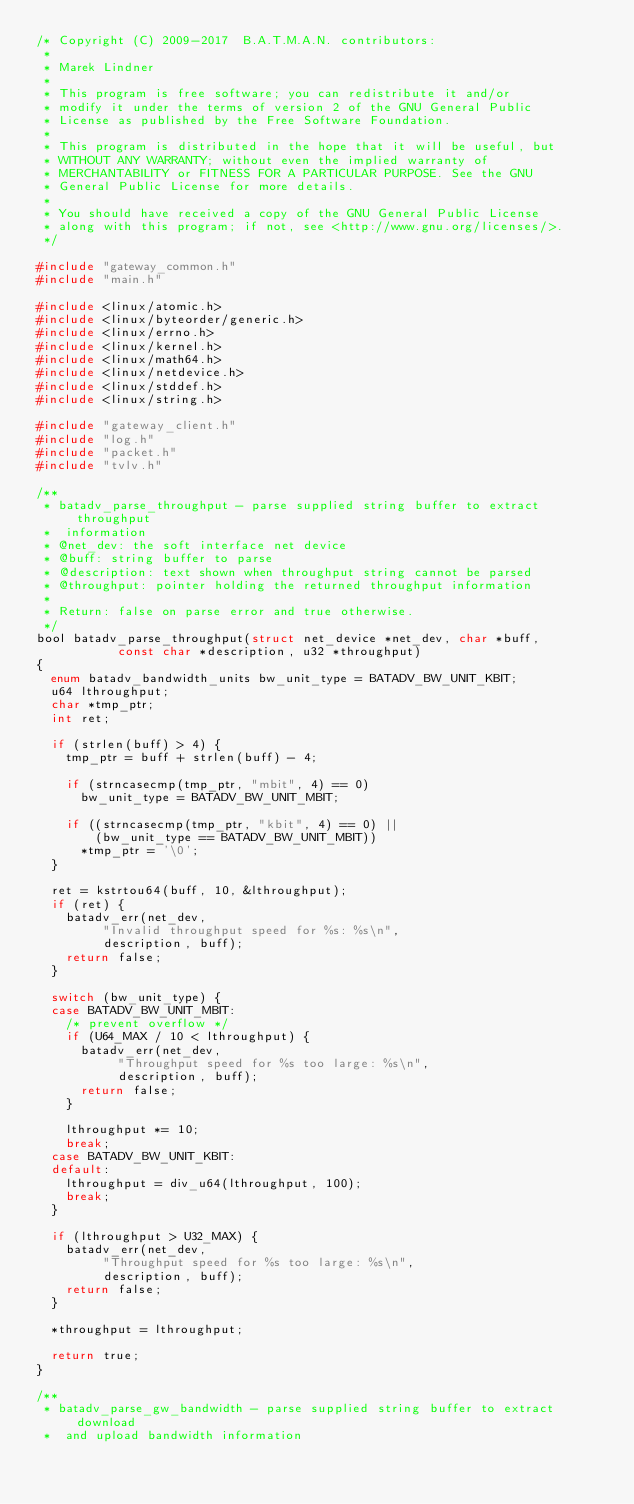<code> <loc_0><loc_0><loc_500><loc_500><_C_>/* Copyright (C) 2009-2017  B.A.T.M.A.N. contributors:
 *
 * Marek Lindner
 *
 * This program is free software; you can redistribute it and/or
 * modify it under the terms of version 2 of the GNU General Public
 * License as published by the Free Software Foundation.
 *
 * This program is distributed in the hope that it will be useful, but
 * WITHOUT ANY WARRANTY; without even the implied warranty of
 * MERCHANTABILITY or FITNESS FOR A PARTICULAR PURPOSE. See the GNU
 * General Public License for more details.
 *
 * You should have received a copy of the GNU General Public License
 * along with this program; if not, see <http://www.gnu.org/licenses/>.
 */

#include "gateway_common.h"
#include "main.h"

#include <linux/atomic.h>
#include <linux/byteorder/generic.h>
#include <linux/errno.h>
#include <linux/kernel.h>
#include <linux/math64.h>
#include <linux/netdevice.h>
#include <linux/stddef.h>
#include <linux/string.h>

#include "gateway_client.h"
#include "log.h"
#include "packet.h"
#include "tvlv.h"

/**
 * batadv_parse_throughput - parse supplied string buffer to extract throughput
 *  information
 * @net_dev: the soft interface net device
 * @buff: string buffer to parse
 * @description: text shown when throughput string cannot be parsed
 * @throughput: pointer holding the returned throughput information
 *
 * Return: false on parse error and true otherwise.
 */
bool batadv_parse_throughput(struct net_device *net_dev, char *buff,
			     const char *description, u32 *throughput)
{
	enum batadv_bandwidth_units bw_unit_type = BATADV_BW_UNIT_KBIT;
	u64 lthroughput;
	char *tmp_ptr;
	int ret;

	if (strlen(buff) > 4) {
		tmp_ptr = buff + strlen(buff) - 4;

		if (strncasecmp(tmp_ptr, "mbit", 4) == 0)
			bw_unit_type = BATADV_BW_UNIT_MBIT;

		if ((strncasecmp(tmp_ptr, "kbit", 4) == 0) ||
		    (bw_unit_type == BATADV_BW_UNIT_MBIT))
			*tmp_ptr = '\0';
	}

	ret = kstrtou64(buff, 10, &lthroughput);
	if (ret) {
		batadv_err(net_dev,
			   "Invalid throughput speed for %s: %s\n",
			   description, buff);
		return false;
	}

	switch (bw_unit_type) {
	case BATADV_BW_UNIT_MBIT:
		/* prevent overflow */
		if (U64_MAX / 10 < lthroughput) {
			batadv_err(net_dev,
				   "Throughput speed for %s too large: %s\n",
				   description, buff);
			return false;
		}

		lthroughput *= 10;
		break;
	case BATADV_BW_UNIT_KBIT:
	default:
		lthroughput = div_u64(lthroughput, 100);
		break;
	}

	if (lthroughput > U32_MAX) {
		batadv_err(net_dev,
			   "Throughput speed for %s too large: %s\n",
			   description, buff);
		return false;
	}

	*throughput = lthroughput;

	return true;
}

/**
 * batadv_parse_gw_bandwidth - parse supplied string buffer to extract download
 *  and upload bandwidth information</code> 